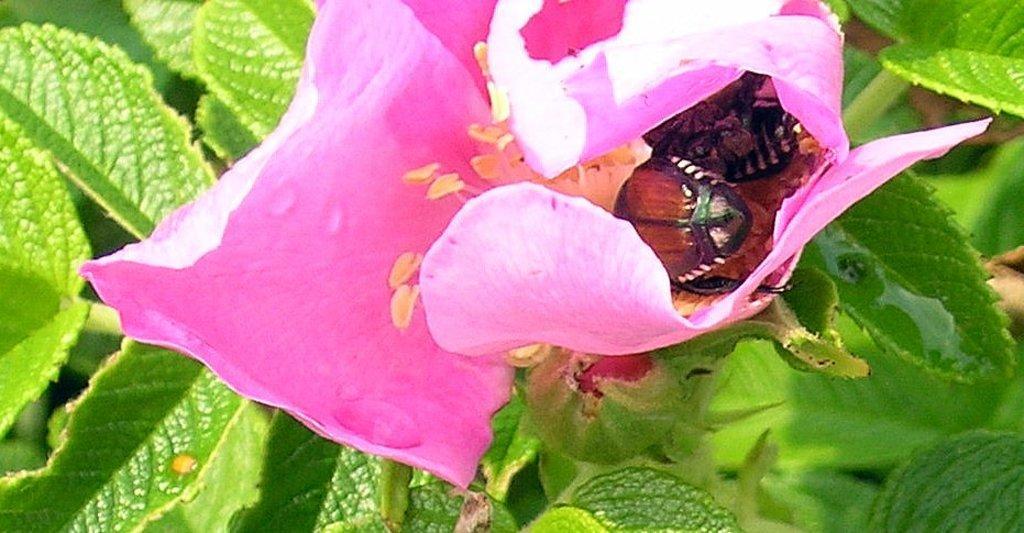Please provide a concise description of this image. In this image we can see a pink color flower in which insects are there. In the background of the image we can see green color leaves. 